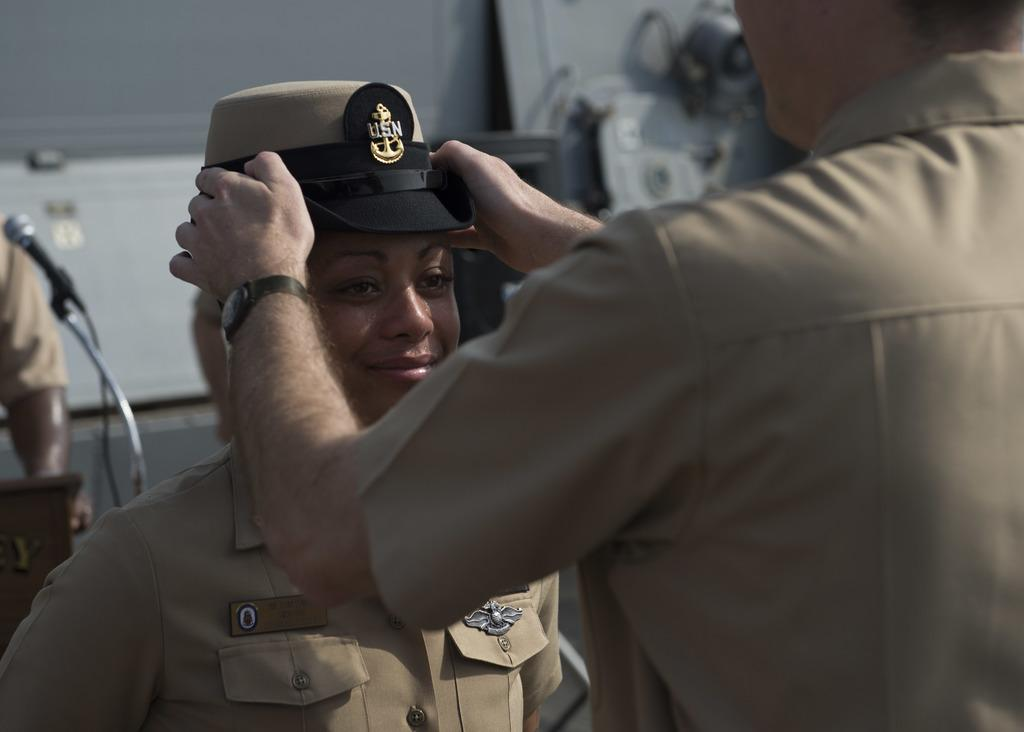How many people are in the image? There are three people in the image. What are the people wearing? The people are wearing the same uniform. Can you describe any accessories in the image? Yes, there is a wrist watch, a cap, and a microphone in the image. What is the purpose of the microphone? The presence of a microphone suggests that the people might be involved in a speaking or performance activity. What is the expression of one of the people in the image? One of the people is smiling. What type of toy can be seen in the hands of the person wearing the cap? There is no toy present in the image; the person wearing the cap is holding a microphone. What subject is the person teaching in the image? There is no indication in the image that the people are involved are teaching a subject. 